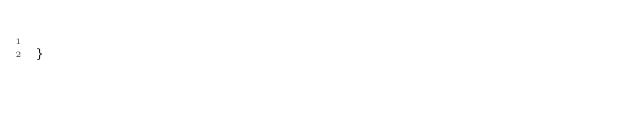Convert code to text. <code><loc_0><loc_0><loc_500><loc_500><_Java_>
}
</code> 